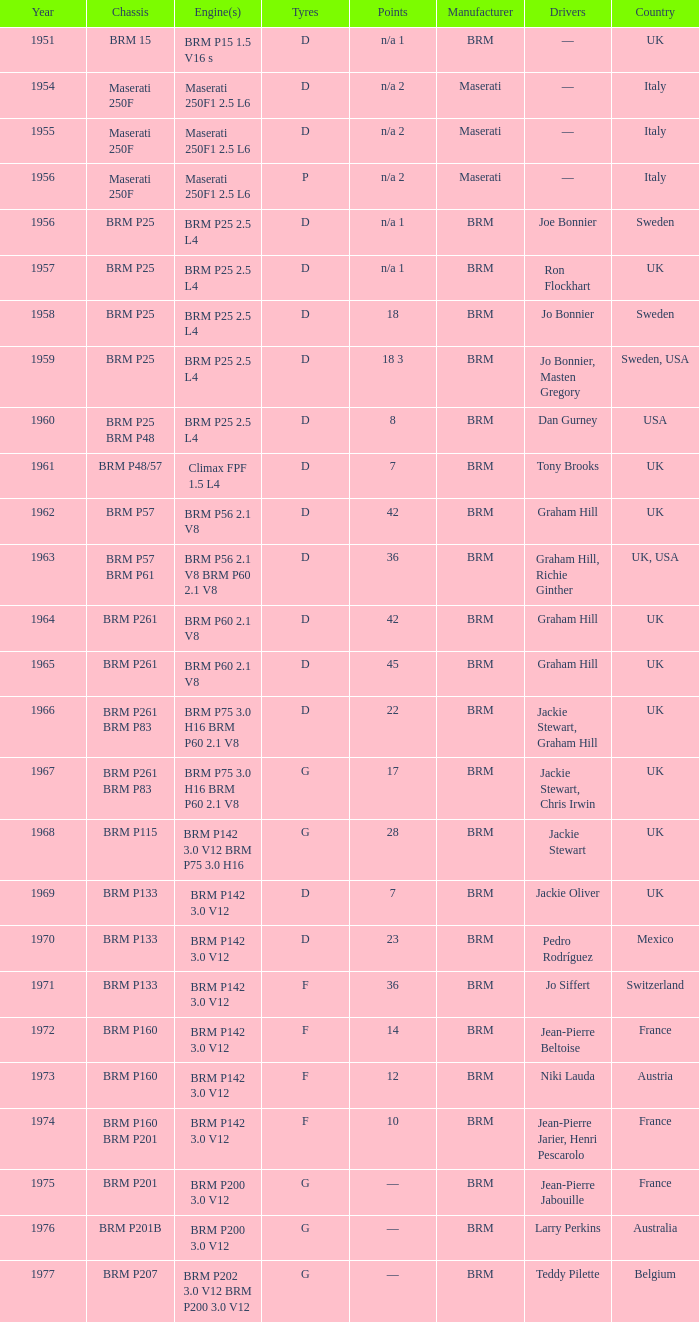What is the cumulative duration of service for the brm p202 3.0 v12 and brm p200 3.0 v12 engines? 1977.0. 